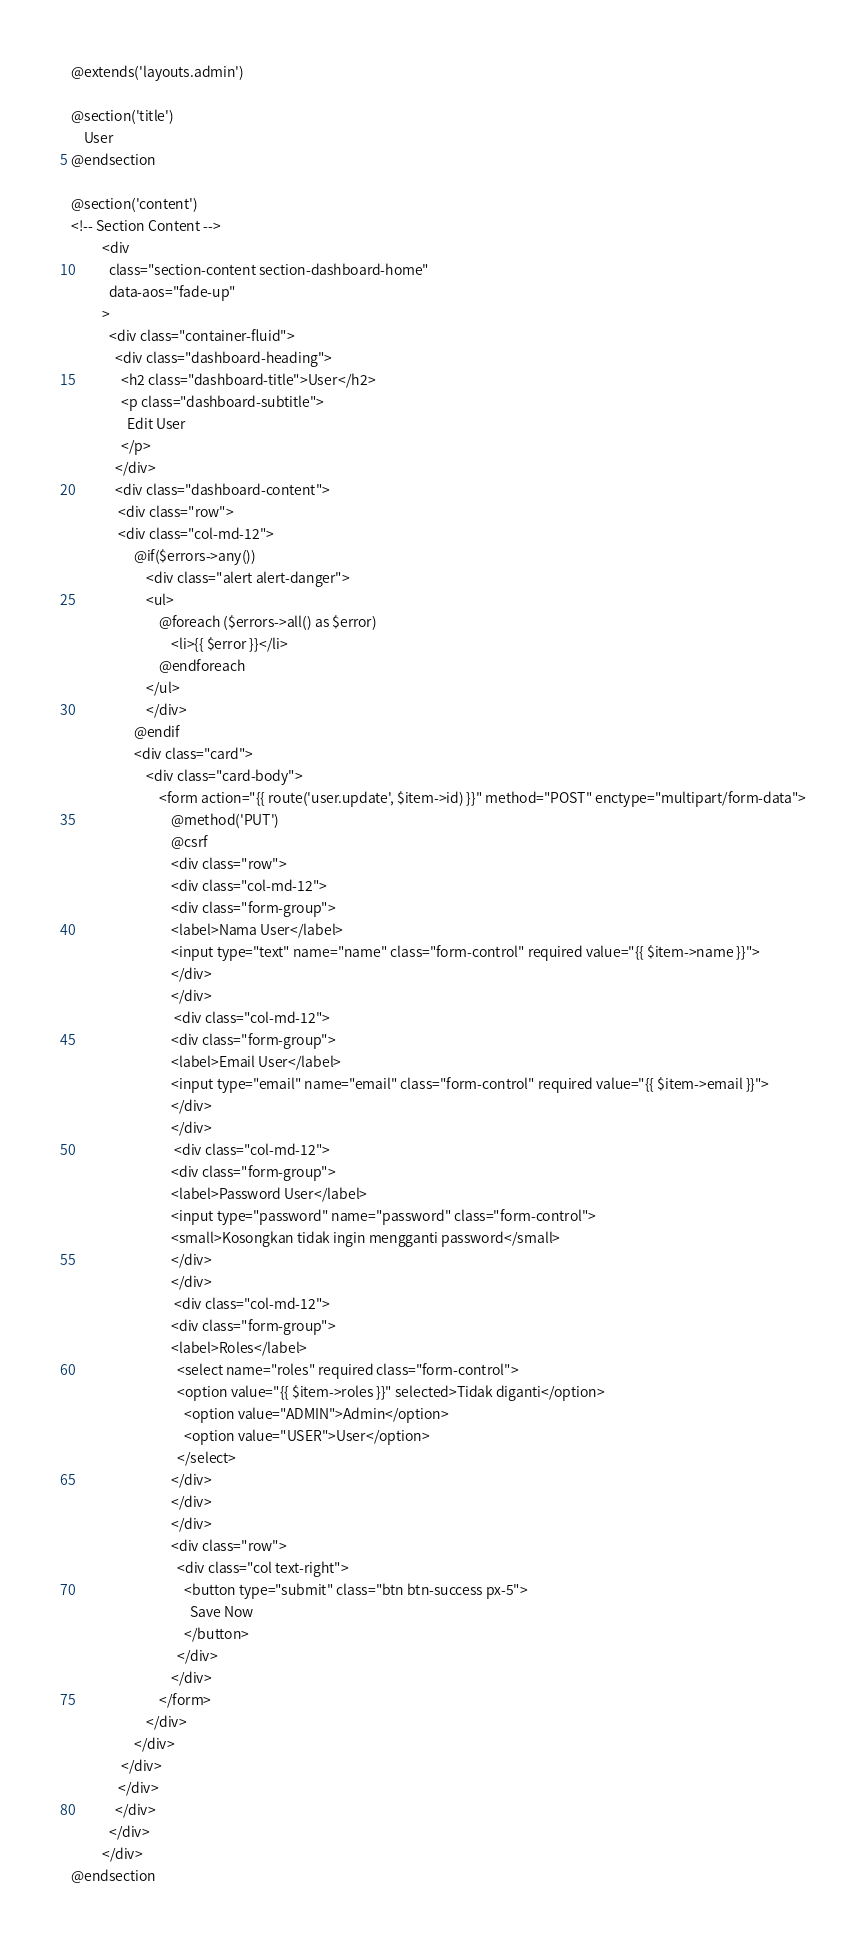<code> <loc_0><loc_0><loc_500><loc_500><_PHP_>@extends('layouts.admin')

@section('title')
    User
@endsection

@section('content')
<!-- Section Content -->
          <div
            class="section-content section-dashboard-home"
            data-aos="fade-up"
          >
            <div class="container-fluid">
              <div class="dashboard-heading">
                <h2 class="dashboard-title">User</h2>
                <p class="dashboard-subtitle">
                  Edit User
                </p>
              </div>
              <div class="dashboard-content">
               <div class="row">
               <div class="col-md-12">
                    @if($errors->any())
                        <div class="alert alert-danger">
                        <ul>
                            @foreach ($errors->all() as $error)
                                <li>{{ $error }}</li>
                            @endforeach
                        </ul>
                        </div>
                    @endif
                    <div class="card">
                        <div class="card-body">
                            <form action="{{ route('user.update', $item->id) }}" method="POST" enctype="multipart/form-data">
                                @method('PUT')
                                @csrf 
                                <div class="row">
                                <div class="col-md-12">
                                <div class="form-group">
                                <label>Nama User</label>
                                <input type="text" name="name" class="form-control" required value="{{ $item->name }}">
                                </div>
                                </div>
                                 <div class="col-md-12">
                                <div class="form-group">
                                <label>Email User</label>
                                <input type="email" name="email" class="form-control" required value="{{ $item->email }}">
                                </div>
                                </div>
                                 <div class="col-md-12">
                                <div class="form-group">
                                <label>Password User</label>
                                <input type="password" name="password" class="form-control">
                                <small>Kosongkan tidak ingin mengganti password</small>
                                </div>
                                </div>
                                 <div class="col-md-12">
                                <div class="form-group">
                                <label>Roles</label>
                                  <select name="roles" required class="form-control">
                                  <option value="{{ $item->roles }}" selected>Tidak diganti</option>
                                    <option value="ADMIN">Admin</option>
                                    <option value="USER">User</option>
                                  </select>
                                </div>
                                </div>
                                </div>
                                <div class="row">
                                  <div class="col text-right">
                                    <button type="submit" class="btn btn-success px-5">
                                      Save Now
                                    </button>
                                  </div>
                                </div>
                            </form>
                        </div> 
                    </div>
                </div>
               </div>
              </div>
            </div>
          </div>
@endsection

</code> 